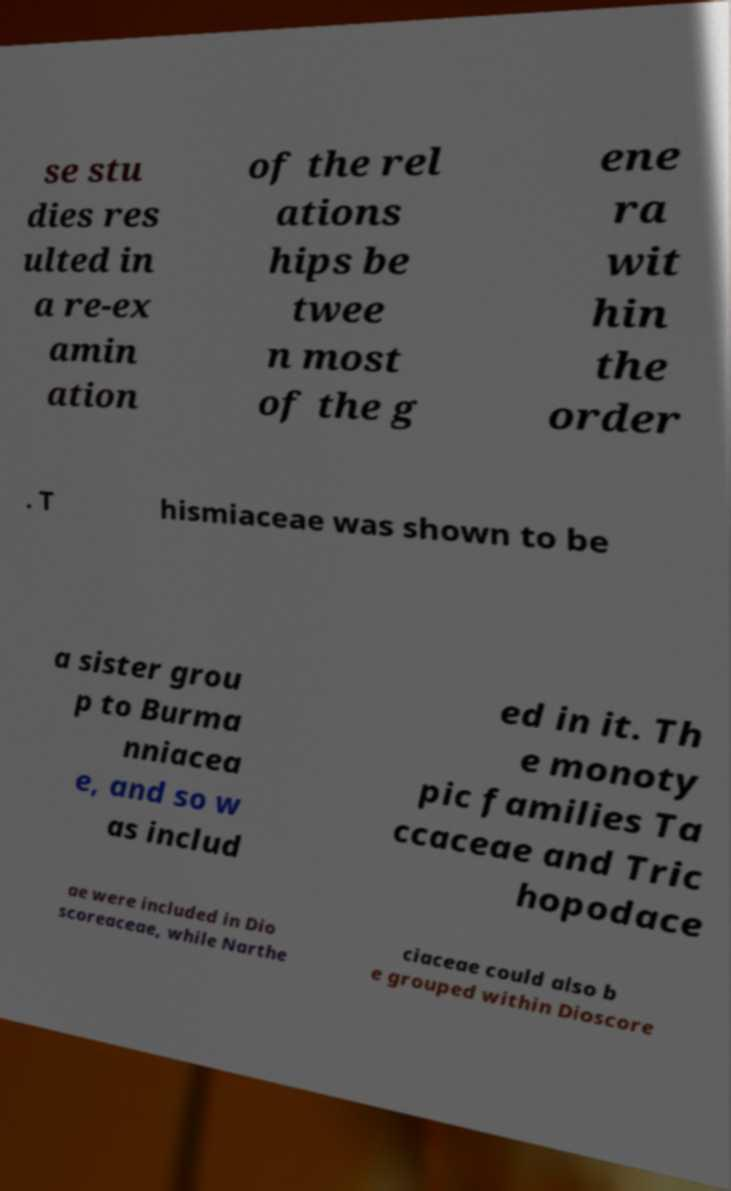Could you extract and type out the text from this image? se stu dies res ulted in a re-ex amin ation of the rel ations hips be twee n most of the g ene ra wit hin the order . T hismiaceae was shown to be a sister grou p to Burma nniacea e, and so w as includ ed in it. Th e monoty pic families Ta ccaceae and Tric hopodace ae were included in Dio scoreaceae, while Narthe ciaceae could also b e grouped within Dioscore 